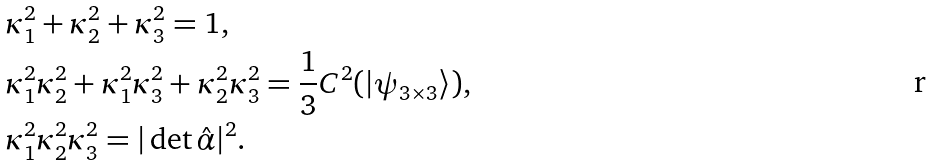Convert formula to latex. <formula><loc_0><loc_0><loc_500><loc_500>& \kappa _ { 1 } ^ { 2 } + \kappa _ { 2 } ^ { 2 } + \kappa _ { 3 } ^ { 2 } = 1 , \\ & \kappa _ { 1 } ^ { 2 } \kappa _ { 2 } ^ { 2 } + \kappa _ { 1 } ^ { 2 } \kappa _ { 3 } ^ { 2 } + \kappa _ { 2 } ^ { 2 } \kappa _ { 3 } ^ { 2 } = \frac { 1 } { 3 } C ^ { 2 } ( | \psi _ { 3 \times 3 } \rangle ) , \\ & \kappa _ { 1 } ^ { 2 } \kappa _ { 2 } ^ { 2 } \kappa _ { 3 } ^ { 2 } = | \det \hat { \alpha } | ^ { 2 } .</formula> 